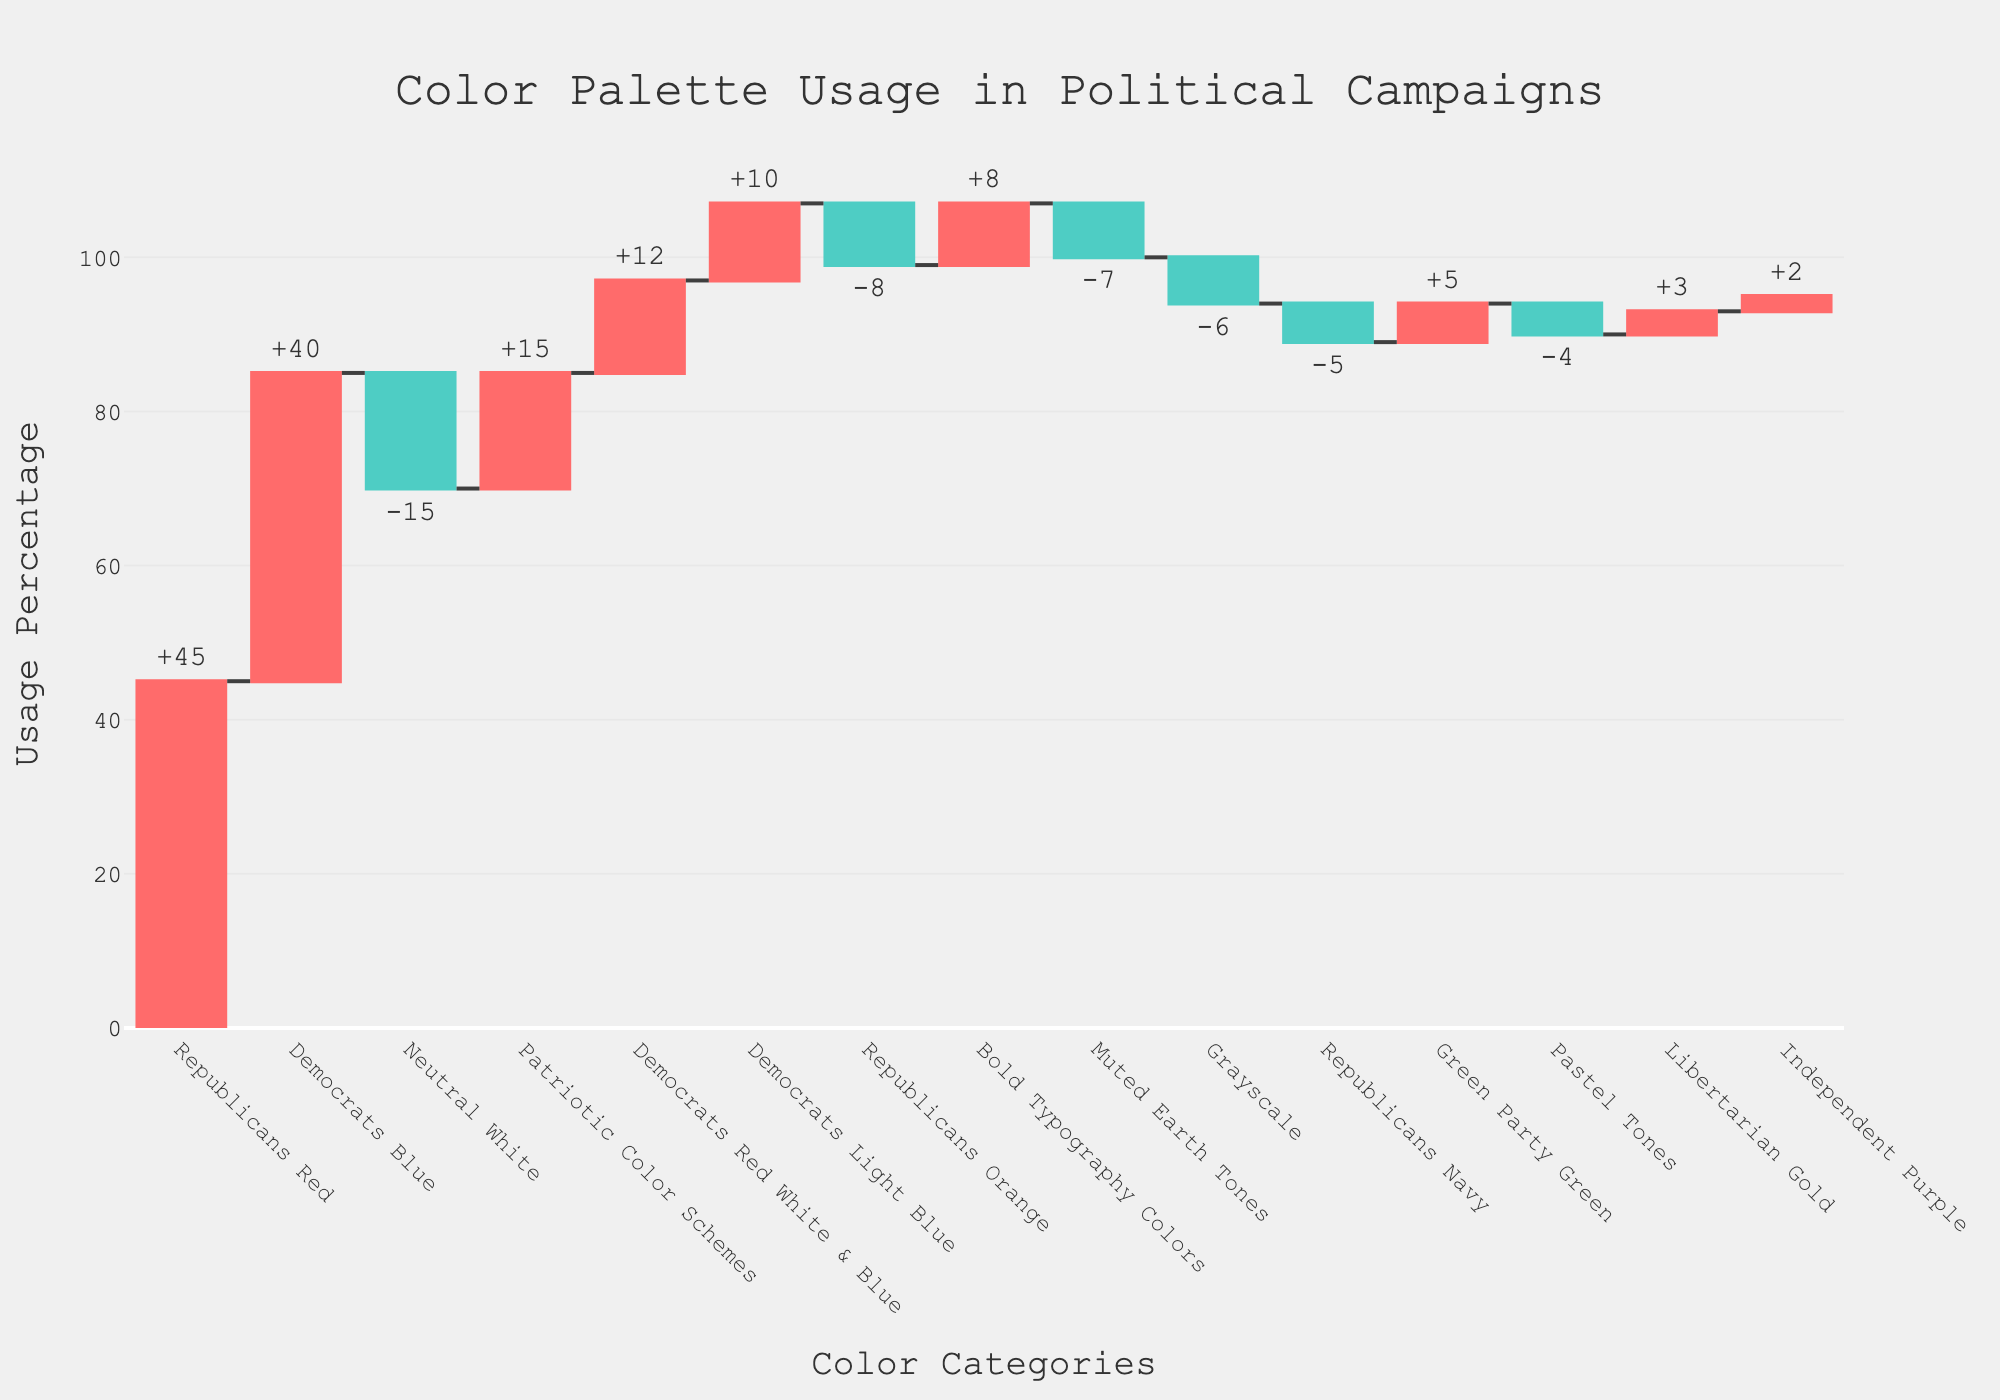What is the title of the chart? The title is usually found at the top of the chart and provides an overview of what the chart represents. In this case, it reads "Color Palette Usage in Political Campaigns".
Answer: Color Palette Usage in Political Campaigns Which category has the highest positive value? To find the highest positive value, look for the tallest bar extending upward. Here, it shows "Republicans Red" with a value of +45.
Answer: Republicans Red How many categories have negative values? Identify all the bars extending downward. There are six categories with negative values: "Neutral White", "Republicans Navy", "Republicans Orange", "Grayscale", "Pastel Tones", and "Muted Earth Tones".
Answer: 6 What is the cumulative effect of the categories "Republicans Red" and "Democrats Blue"? The values for "Republicans Red" and "Democrats Blue" are +45 and +40, respectively. Adding these together gives the cumulative effect. 45 + 40 = 85
Answer: 85 Which party has a higher use of neutral colors? Compare the Neutral White bar with values representing specific parties. "Neutral White" has a value of -15. The other parties have no negative values as significant as this for neutral tones.
Answer: Neutral White How does the use of bold typography colors compare to pastel tones? Look at the bars for "Bold Typography Colors" and "Pastel Tones". "Bold Typography Colors" has a value of +8 while "Pastel Tones" has a value of -4.
Answer: Bold Typography Colors are used more What’s the total contribution from the "Democrats Red White & Blue" and "Patriotic Color Schemes" categories? The values for these categories are +12 and +15, respectively. Adding these values gives: 12 + 15 = 27
Answer: 27 What are the colors of the increasing and decreasing markers in the chart? The waterfall chart typically uses color to differentiate increases and decreases. The increasing markers are marked in a positive color, while the decreasing ones are in a different hue. Here, the positive values are shown in red and negative values in teal.
Answer: red and teal How many categories fall under the 'Republicans' in this chart? Check the categories that specifically mention "Republicans". They are "Republicans Red", "Republicans Navy", and "Republicans Orange".
Answer: 3 Which categories contribute to a decrease in the overall use of colors in campaign materials? These would be the bars extending downward which indicate a negative value. The categories are "Neutral White", "Republicans Navy", "Republicans Orange", "Grayscale", "Pastel Tones", and "Muted Earth Tones".
Answer: Neutral White, Republicans Navy, Republicans Orange, Grayscale, Pastel Tones, and Muted Earth Tones 